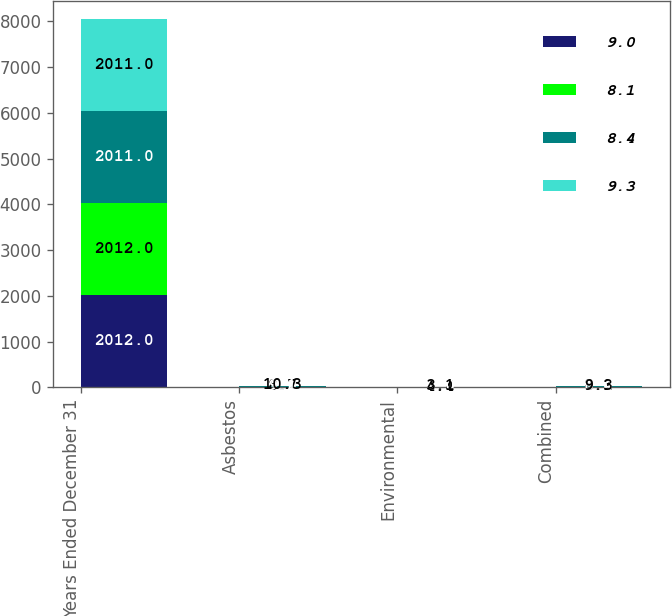Convert chart to OTSL. <chart><loc_0><loc_0><loc_500><loc_500><stacked_bar_chart><ecel><fcel>Years Ended December 31<fcel>Asbestos<fcel>Environmental<fcel>Combined<nl><fcel>9<fcel>2012<fcel>9.6<fcel>4.5<fcel>9<nl><fcel>8.1<fcel>2012<fcel>8.7<fcel>4.4<fcel>8.1<nl><fcel>8.4<fcel>2011<fcel>9.1<fcel>3<fcel>8.4<nl><fcel>9.3<fcel>2011<fcel>10.3<fcel>3.1<fcel>9.3<nl></chart> 